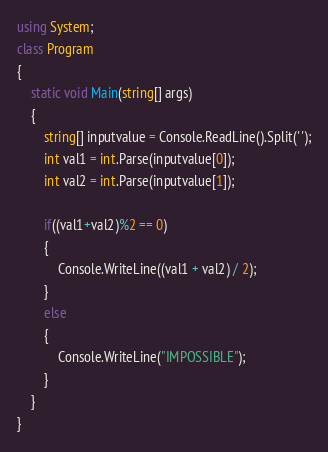<code> <loc_0><loc_0><loc_500><loc_500><_C#_>using System;
class Program
{
    static void Main(string[] args)
    {
        string[] inputvalue = Console.ReadLine().Split(' ');
        int val1 = int.Parse(inputvalue[0]);
        int val2 = int.Parse(inputvalue[1]);
        
        if((val1+val2)%2 == 0)
        {
            Console.WriteLine((val1 + val2) / 2);
        }
        else
        {
            Console.WriteLine("IMPOSSIBLE");
        }
    }
}

</code> 